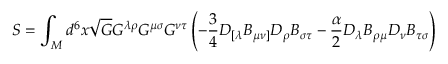<formula> <loc_0><loc_0><loc_500><loc_500>S = \int _ { M } d ^ { 6 } x \sqrt { G } G ^ { \lambda \rho } G ^ { \mu \sigma } G ^ { \nu \tau } \left ( - \frac { 3 } { 4 } D _ { [ \lambda } B _ { \mu \nu ] } D _ { \rho } B _ { \sigma \tau } - \frac { \alpha } { 2 } D _ { \lambda } B _ { \rho \mu } D _ { \nu } B _ { \tau \sigma } \right )</formula> 